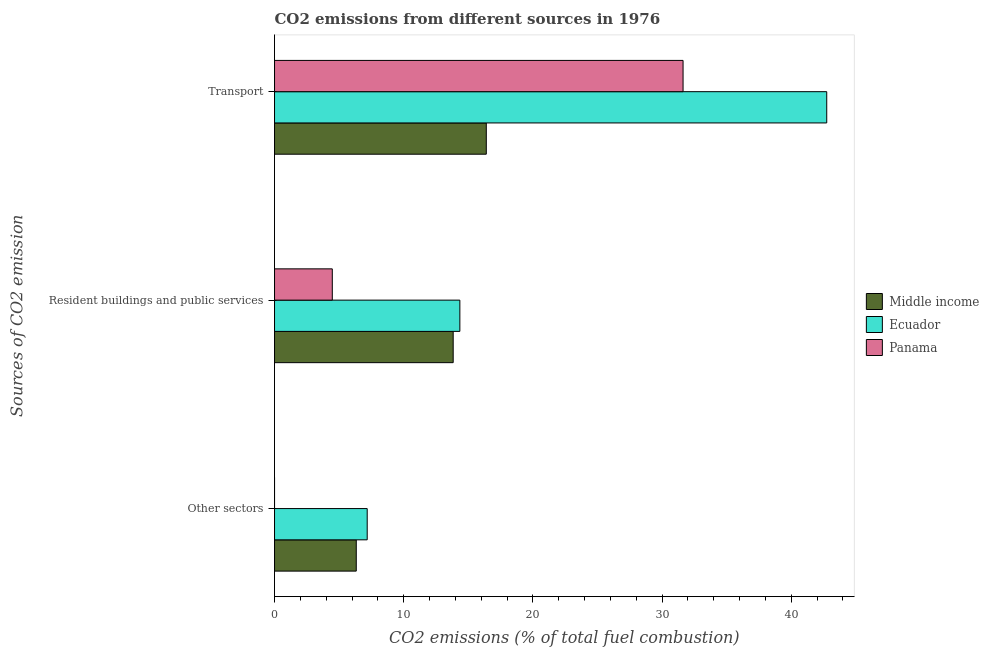How many different coloured bars are there?
Offer a terse response. 3. How many groups of bars are there?
Ensure brevity in your answer.  3. Are the number of bars per tick equal to the number of legend labels?
Give a very brief answer. Yes. Are the number of bars on each tick of the Y-axis equal?
Ensure brevity in your answer.  Yes. What is the label of the 2nd group of bars from the top?
Your answer should be very brief. Resident buildings and public services. What is the percentage of co2 emissions from transport in Ecuador?
Offer a very short reply. 42.75. Across all countries, what is the maximum percentage of co2 emissions from transport?
Give a very brief answer. 42.75. Across all countries, what is the minimum percentage of co2 emissions from resident buildings and public services?
Offer a terse response. 4.47. In which country was the percentage of co2 emissions from transport maximum?
Make the answer very short. Ecuador. What is the total percentage of co2 emissions from resident buildings and public services in the graph?
Your answer should be compact. 32.65. What is the difference between the percentage of co2 emissions from transport in Middle income and that in Panama?
Make the answer very short. -15.23. What is the difference between the percentage of co2 emissions from resident buildings and public services in Panama and the percentage of co2 emissions from other sectors in Ecuador?
Provide a succinct answer. -2.7. What is the average percentage of co2 emissions from resident buildings and public services per country?
Provide a short and direct response. 10.88. What is the difference between the percentage of co2 emissions from resident buildings and public services and percentage of co2 emissions from other sectors in Panama?
Ensure brevity in your answer.  4.47. In how many countries, is the percentage of co2 emissions from resident buildings and public services greater than 28 %?
Your answer should be compact. 0. What is the ratio of the percentage of co2 emissions from other sectors in Ecuador to that in Panama?
Your response must be concise. 1.6180780669980988e+16. Is the percentage of co2 emissions from other sectors in Ecuador less than that in Middle income?
Provide a succinct answer. No. What is the difference between the highest and the second highest percentage of co2 emissions from other sectors?
Your answer should be compact. 0.85. What is the difference between the highest and the lowest percentage of co2 emissions from transport?
Your response must be concise. 26.36. Is the sum of the percentage of co2 emissions from other sectors in Ecuador and Middle income greater than the maximum percentage of co2 emissions from transport across all countries?
Your answer should be very brief. No. What does the 2nd bar from the top in Other sectors represents?
Give a very brief answer. Ecuador. What does the 3rd bar from the bottom in Resident buildings and public services represents?
Provide a succinct answer. Panama. Is it the case that in every country, the sum of the percentage of co2 emissions from other sectors and percentage of co2 emissions from resident buildings and public services is greater than the percentage of co2 emissions from transport?
Provide a short and direct response. No. Are all the bars in the graph horizontal?
Provide a short and direct response. Yes. Does the graph contain any zero values?
Ensure brevity in your answer.  No. Where does the legend appear in the graph?
Keep it short and to the point. Center right. How are the legend labels stacked?
Keep it short and to the point. Vertical. What is the title of the graph?
Keep it short and to the point. CO2 emissions from different sources in 1976. Does "United Arab Emirates" appear as one of the legend labels in the graph?
Make the answer very short. No. What is the label or title of the X-axis?
Keep it short and to the point. CO2 emissions (% of total fuel combustion). What is the label or title of the Y-axis?
Your answer should be very brief. Sources of CO2 emission. What is the CO2 emissions (% of total fuel combustion) in Middle income in Other sectors?
Offer a terse response. 6.33. What is the CO2 emissions (% of total fuel combustion) in Ecuador in Other sectors?
Offer a very short reply. 7.17. What is the CO2 emissions (% of total fuel combustion) in Panama in Other sectors?
Keep it short and to the point. 4.43379802166596e-16. What is the CO2 emissions (% of total fuel combustion) of Middle income in Resident buildings and public services?
Offer a very short reply. 13.83. What is the CO2 emissions (% of total fuel combustion) in Ecuador in Resident buildings and public services?
Give a very brief answer. 14.35. What is the CO2 emissions (% of total fuel combustion) of Panama in Resident buildings and public services?
Your response must be concise. 4.47. What is the CO2 emissions (% of total fuel combustion) in Middle income in Transport?
Make the answer very short. 16.39. What is the CO2 emissions (% of total fuel combustion) in Ecuador in Transport?
Make the answer very short. 42.75. What is the CO2 emissions (% of total fuel combustion) of Panama in Transport?
Provide a succinct answer. 31.63. Across all Sources of CO2 emission, what is the maximum CO2 emissions (% of total fuel combustion) of Middle income?
Ensure brevity in your answer.  16.39. Across all Sources of CO2 emission, what is the maximum CO2 emissions (% of total fuel combustion) in Ecuador?
Give a very brief answer. 42.75. Across all Sources of CO2 emission, what is the maximum CO2 emissions (% of total fuel combustion) of Panama?
Keep it short and to the point. 31.63. Across all Sources of CO2 emission, what is the minimum CO2 emissions (% of total fuel combustion) of Middle income?
Ensure brevity in your answer.  6.33. Across all Sources of CO2 emission, what is the minimum CO2 emissions (% of total fuel combustion) of Ecuador?
Your response must be concise. 7.17. Across all Sources of CO2 emission, what is the minimum CO2 emissions (% of total fuel combustion) in Panama?
Make the answer very short. 4.43379802166596e-16. What is the total CO2 emissions (% of total fuel combustion) in Middle income in the graph?
Provide a short and direct response. 36.55. What is the total CO2 emissions (% of total fuel combustion) in Ecuador in the graph?
Make the answer very short. 64.28. What is the total CO2 emissions (% of total fuel combustion) of Panama in the graph?
Provide a short and direct response. 36.1. What is the difference between the CO2 emissions (% of total fuel combustion) of Middle income in Other sectors and that in Resident buildings and public services?
Make the answer very short. -7.5. What is the difference between the CO2 emissions (% of total fuel combustion) in Ecuador in Other sectors and that in Resident buildings and public services?
Give a very brief answer. -7.17. What is the difference between the CO2 emissions (% of total fuel combustion) of Panama in Other sectors and that in Resident buildings and public services?
Provide a succinct answer. -4.47. What is the difference between the CO2 emissions (% of total fuel combustion) of Middle income in Other sectors and that in Transport?
Your answer should be very brief. -10.07. What is the difference between the CO2 emissions (% of total fuel combustion) in Ecuador in Other sectors and that in Transport?
Provide a short and direct response. -35.58. What is the difference between the CO2 emissions (% of total fuel combustion) of Panama in Other sectors and that in Transport?
Offer a terse response. -31.63. What is the difference between the CO2 emissions (% of total fuel combustion) in Middle income in Resident buildings and public services and that in Transport?
Make the answer very short. -2.56. What is the difference between the CO2 emissions (% of total fuel combustion) in Ecuador in Resident buildings and public services and that in Transport?
Make the answer very short. -28.4. What is the difference between the CO2 emissions (% of total fuel combustion) of Panama in Resident buildings and public services and that in Transport?
Offer a very short reply. -27.16. What is the difference between the CO2 emissions (% of total fuel combustion) in Middle income in Other sectors and the CO2 emissions (% of total fuel combustion) in Ecuador in Resident buildings and public services?
Offer a terse response. -8.02. What is the difference between the CO2 emissions (% of total fuel combustion) in Middle income in Other sectors and the CO2 emissions (% of total fuel combustion) in Panama in Resident buildings and public services?
Ensure brevity in your answer.  1.86. What is the difference between the CO2 emissions (% of total fuel combustion) in Ecuador in Other sectors and the CO2 emissions (% of total fuel combustion) in Panama in Resident buildings and public services?
Keep it short and to the point. 2.7. What is the difference between the CO2 emissions (% of total fuel combustion) of Middle income in Other sectors and the CO2 emissions (% of total fuel combustion) of Ecuador in Transport?
Your answer should be compact. -36.42. What is the difference between the CO2 emissions (% of total fuel combustion) of Middle income in Other sectors and the CO2 emissions (% of total fuel combustion) of Panama in Transport?
Offer a very short reply. -25.3. What is the difference between the CO2 emissions (% of total fuel combustion) in Ecuador in Other sectors and the CO2 emissions (% of total fuel combustion) in Panama in Transport?
Keep it short and to the point. -24.46. What is the difference between the CO2 emissions (% of total fuel combustion) of Middle income in Resident buildings and public services and the CO2 emissions (% of total fuel combustion) of Ecuador in Transport?
Offer a very short reply. -28.92. What is the difference between the CO2 emissions (% of total fuel combustion) in Middle income in Resident buildings and public services and the CO2 emissions (% of total fuel combustion) in Panama in Transport?
Keep it short and to the point. -17.8. What is the difference between the CO2 emissions (% of total fuel combustion) of Ecuador in Resident buildings and public services and the CO2 emissions (% of total fuel combustion) of Panama in Transport?
Provide a short and direct response. -17.28. What is the average CO2 emissions (% of total fuel combustion) of Middle income per Sources of CO2 emission?
Your answer should be very brief. 12.18. What is the average CO2 emissions (% of total fuel combustion) of Ecuador per Sources of CO2 emission?
Ensure brevity in your answer.  21.43. What is the average CO2 emissions (% of total fuel combustion) of Panama per Sources of CO2 emission?
Your response must be concise. 12.03. What is the difference between the CO2 emissions (% of total fuel combustion) in Middle income and CO2 emissions (% of total fuel combustion) in Ecuador in Other sectors?
Your answer should be very brief. -0.85. What is the difference between the CO2 emissions (% of total fuel combustion) in Middle income and CO2 emissions (% of total fuel combustion) in Panama in Other sectors?
Give a very brief answer. 6.33. What is the difference between the CO2 emissions (% of total fuel combustion) of Ecuador and CO2 emissions (% of total fuel combustion) of Panama in Other sectors?
Provide a short and direct response. 7.17. What is the difference between the CO2 emissions (% of total fuel combustion) of Middle income and CO2 emissions (% of total fuel combustion) of Ecuador in Resident buildings and public services?
Keep it short and to the point. -0.52. What is the difference between the CO2 emissions (% of total fuel combustion) of Middle income and CO2 emissions (% of total fuel combustion) of Panama in Resident buildings and public services?
Offer a very short reply. 9.36. What is the difference between the CO2 emissions (% of total fuel combustion) of Ecuador and CO2 emissions (% of total fuel combustion) of Panama in Resident buildings and public services?
Your response must be concise. 9.88. What is the difference between the CO2 emissions (% of total fuel combustion) of Middle income and CO2 emissions (% of total fuel combustion) of Ecuador in Transport?
Your response must be concise. -26.36. What is the difference between the CO2 emissions (% of total fuel combustion) of Middle income and CO2 emissions (% of total fuel combustion) of Panama in Transport?
Keep it short and to the point. -15.23. What is the difference between the CO2 emissions (% of total fuel combustion) in Ecuador and CO2 emissions (% of total fuel combustion) in Panama in Transport?
Your answer should be compact. 11.12. What is the ratio of the CO2 emissions (% of total fuel combustion) in Middle income in Other sectors to that in Resident buildings and public services?
Make the answer very short. 0.46. What is the ratio of the CO2 emissions (% of total fuel combustion) in Panama in Other sectors to that in Resident buildings and public services?
Give a very brief answer. 0. What is the ratio of the CO2 emissions (% of total fuel combustion) of Middle income in Other sectors to that in Transport?
Ensure brevity in your answer.  0.39. What is the ratio of the CO2 emissions (% of total fuel combustion) of Ecuador in Other sectors to that in Transport?
Make the answer very short. 0.17. What is the ratio of the CO2 emissions (% of total fuel combustion) of Middle income in Resident buildings and public services to that in Transport?
Your response must be concise. 0.84. What is the ratio of the CO2 emissions (% of total fuel combustion) in Ecuador in Resident buildings and public services to that in Transport?
Keep it short and to the point. 0.34. What is the ratio of the CO2 emissions (% of total fuel combustion) in Panama in Resident buildings and public services to that in Transport?
Give a very brief answer. 0.14. What is the difference between the highest and the second highest CO2 emissions (% of total fuel combustion) of Middle income?
Offer a very short reply. 2.56. What is the difference between the highest and the second highest CO2 emissions (% of total fuel combustion) of Ecuador?
Your answer should be compact. 28.4. What is the difference between the highest and the second highest CO2 emissions (% of total fuel combustion) of Panama?
Your answer should be compact. 27.16. What is the difference between the highest and the lowest CO2 emissions (% of total fuel combustion) in Middle income?
Make the answer very short. 10.07. What is the difference between the highest and the lowest CO2 emissions (% of total fuel combustion) in Ecuador?
Give a very brief answer. 35.58. What is the difference between the highest and the lowest CO2 emissions (% of total fuel combustion) of Panama?
Your answer should be compact. 31.63. 